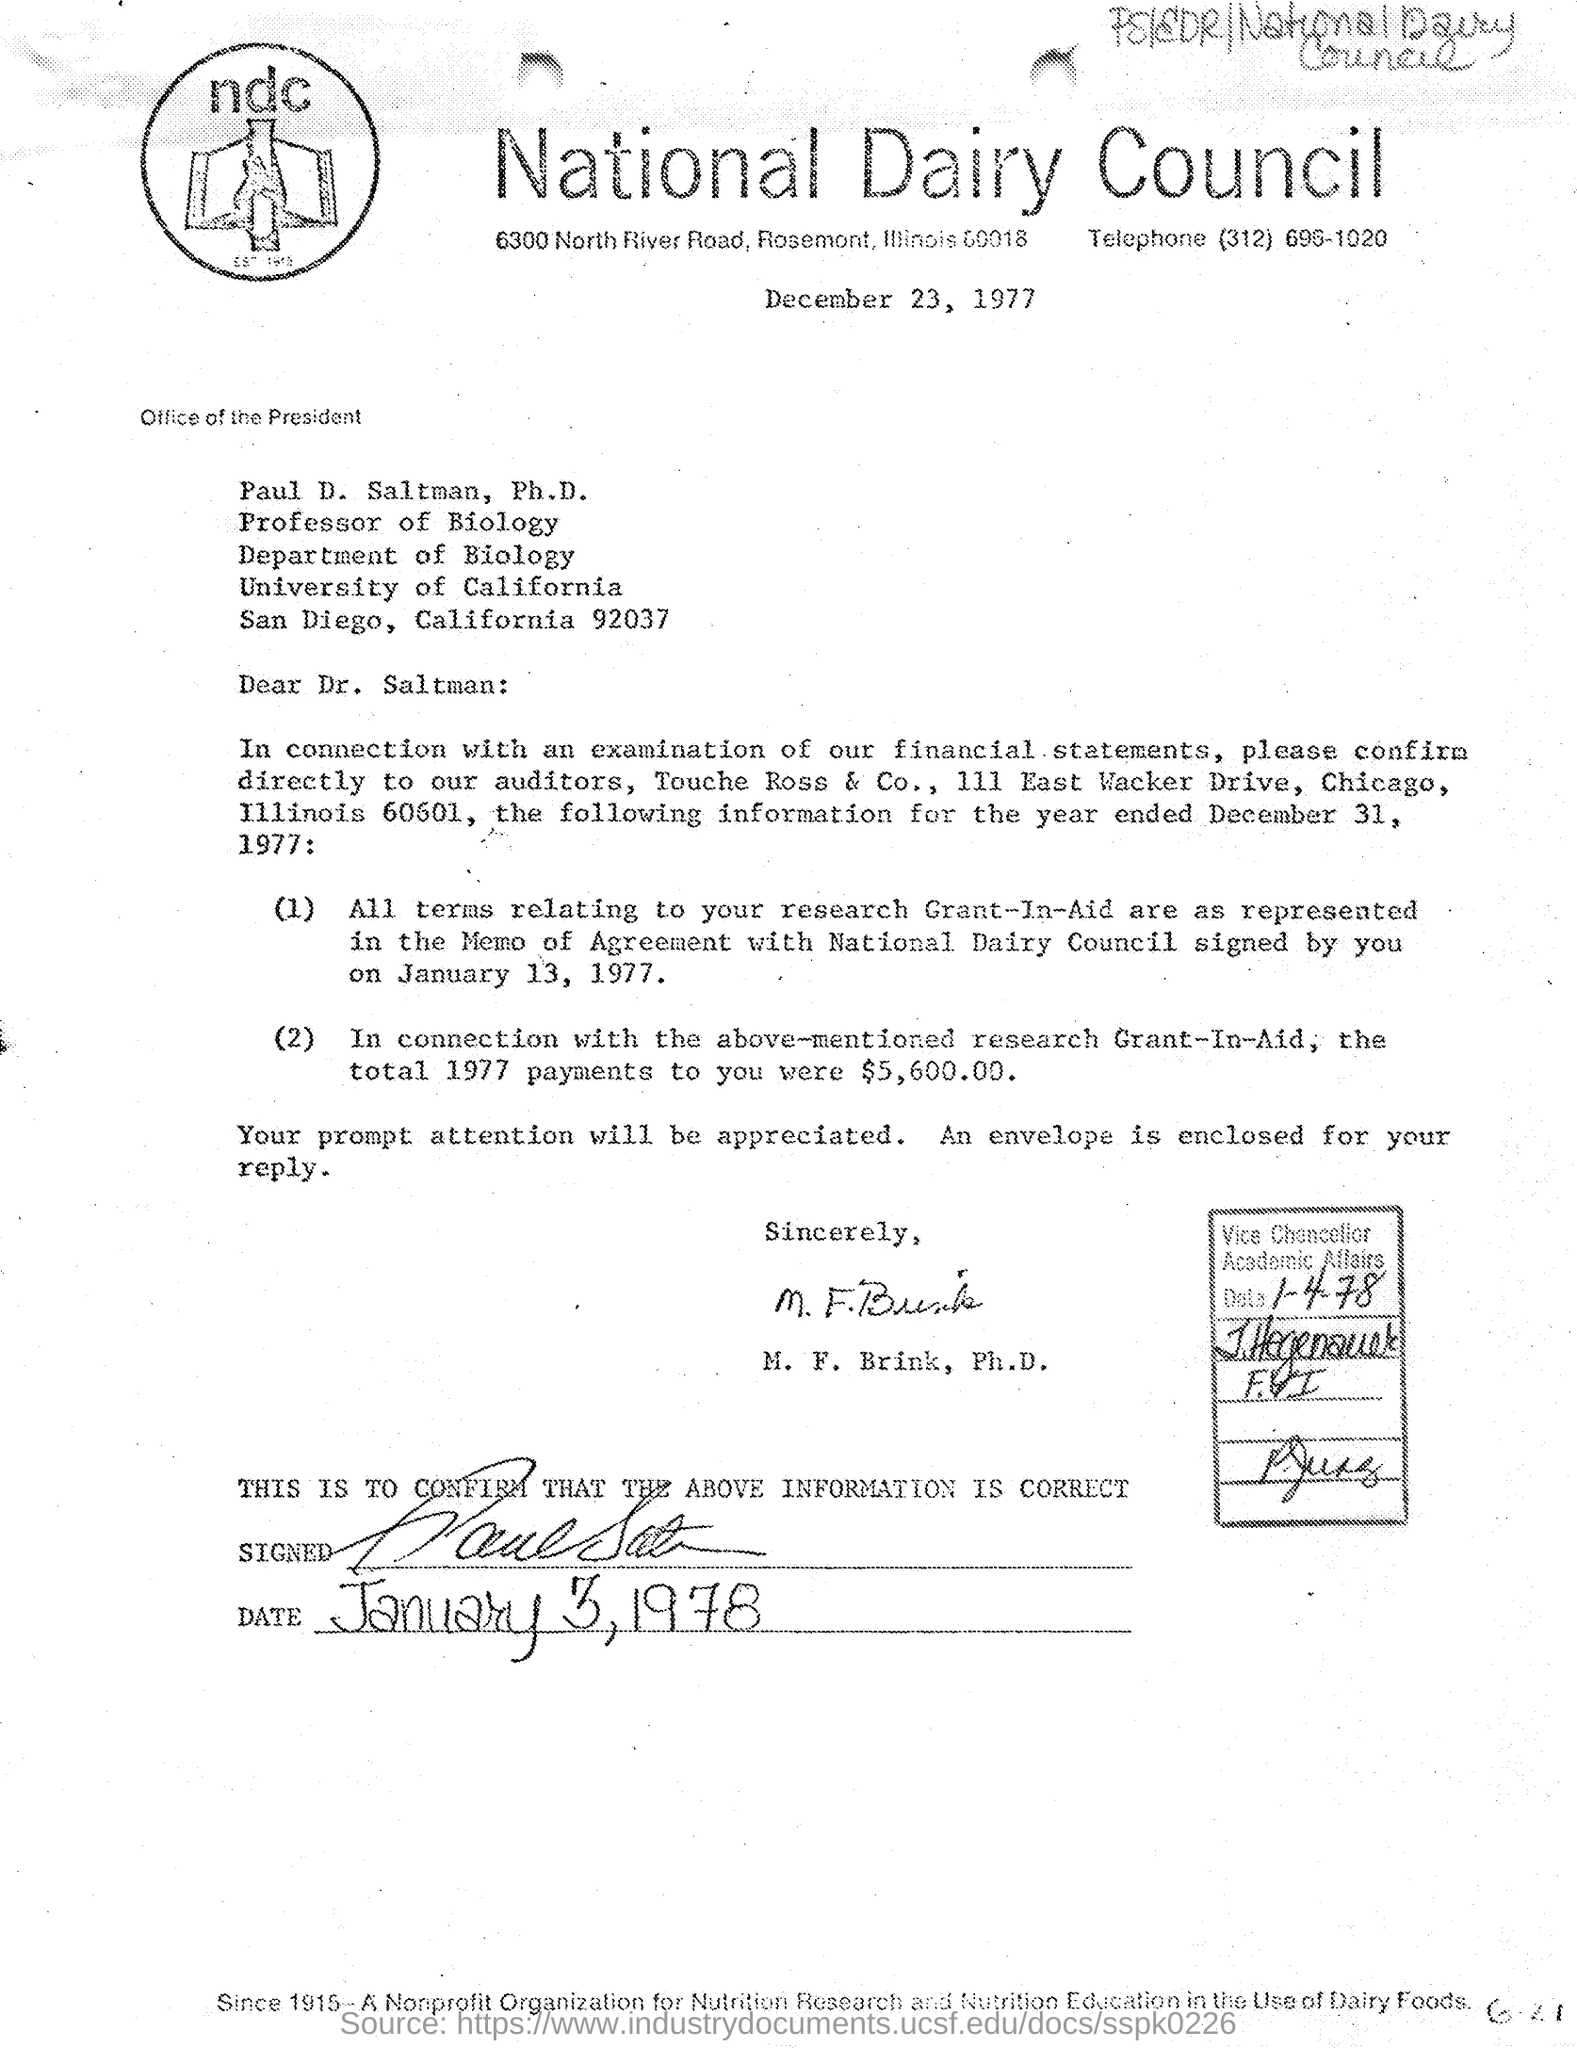Give some essential details in this illustration. This letter is addressed to Dr. Saltman. The telephone number mentioned is (312) 696-1020. 